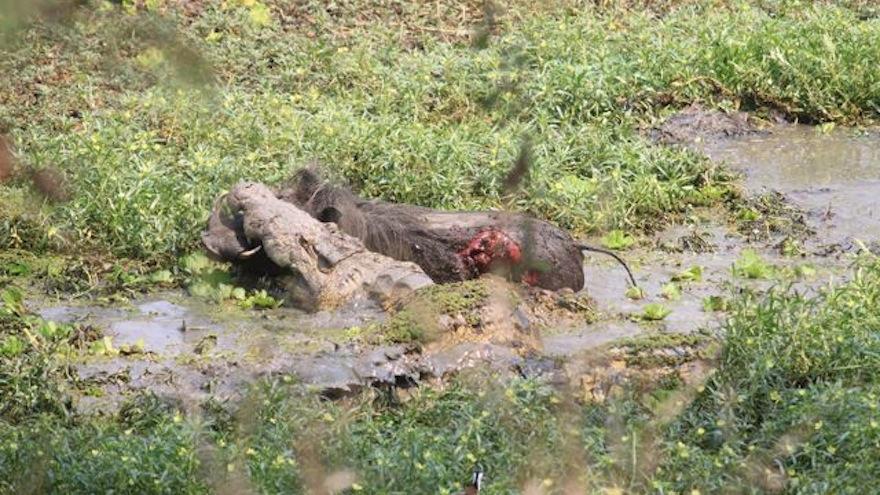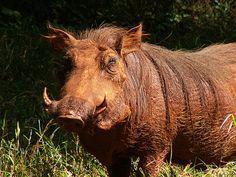The first image is the image on the left, the second image is the image on the right. For the images shown, is this caption "Baby warthogs are standing close to their mother." true? Answer yes or no. No. The first image is the image on the left, the second image is the image on the right. Analyze the images presented: Is the assertion "An image shows one adult warthog near two small young warthogs." valid? Answer yes or no. No. 